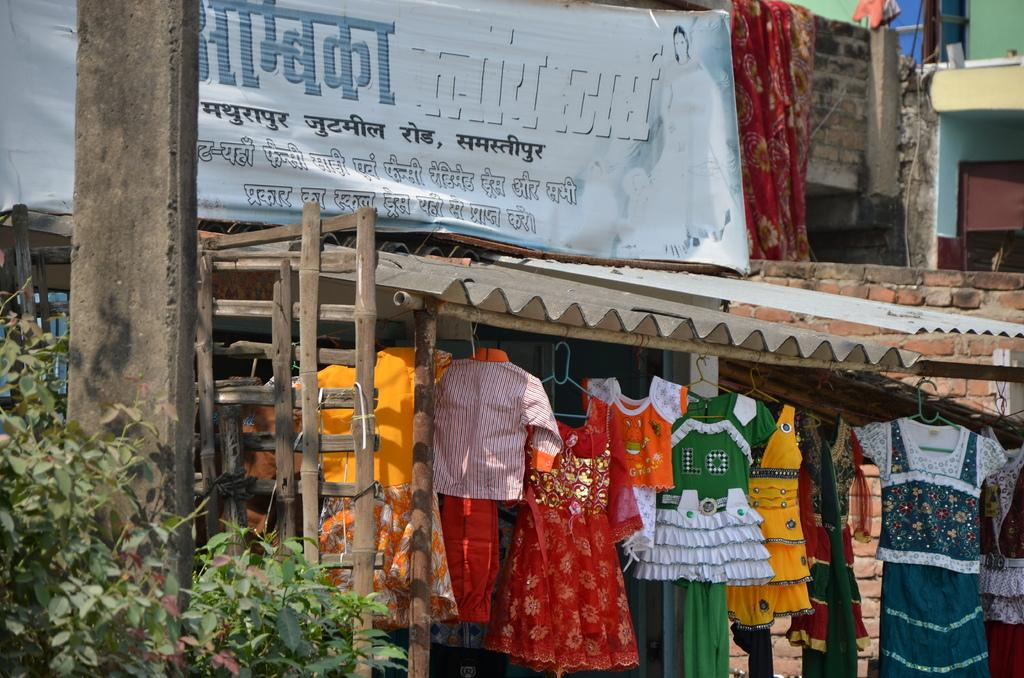What type of structures can be seen in the image? There are buildings in the image. What object is present in the image that might be used for displaying information? There is a board in the image. What can be seen hanging or placed on the buildings? Clothes are visible in the image. What is written or displayed on the board? Something is written on the board. Where is a specific object located on the left side of the image? There is a pole on the left side of the image. What type of living organism is also present on the left side of the image? There is a plant on the left side of the image. How many passengers are waiting in the hall for the police to arrive in the image? There is no hall, passengers, or police present in the image. What type of police equipment can be seen on the plant in the image? There is no police equipment or plant with any equipment in the image. 